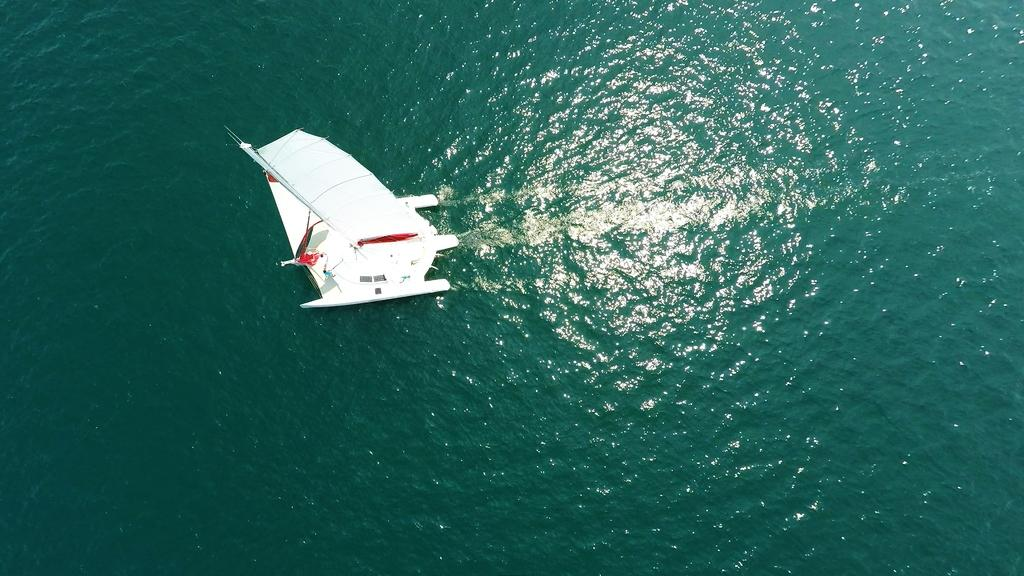What is the main subject of the image? The main subject of the image is a boat. Where is the boat located? The boat is on the water. How many sails are visible on the boat in the image? There is no information about sails on the boat in the image, so we cannot determine the number of sails. What type of cent is present in the image? There is no cent present in the image; it features a boat on the water. 